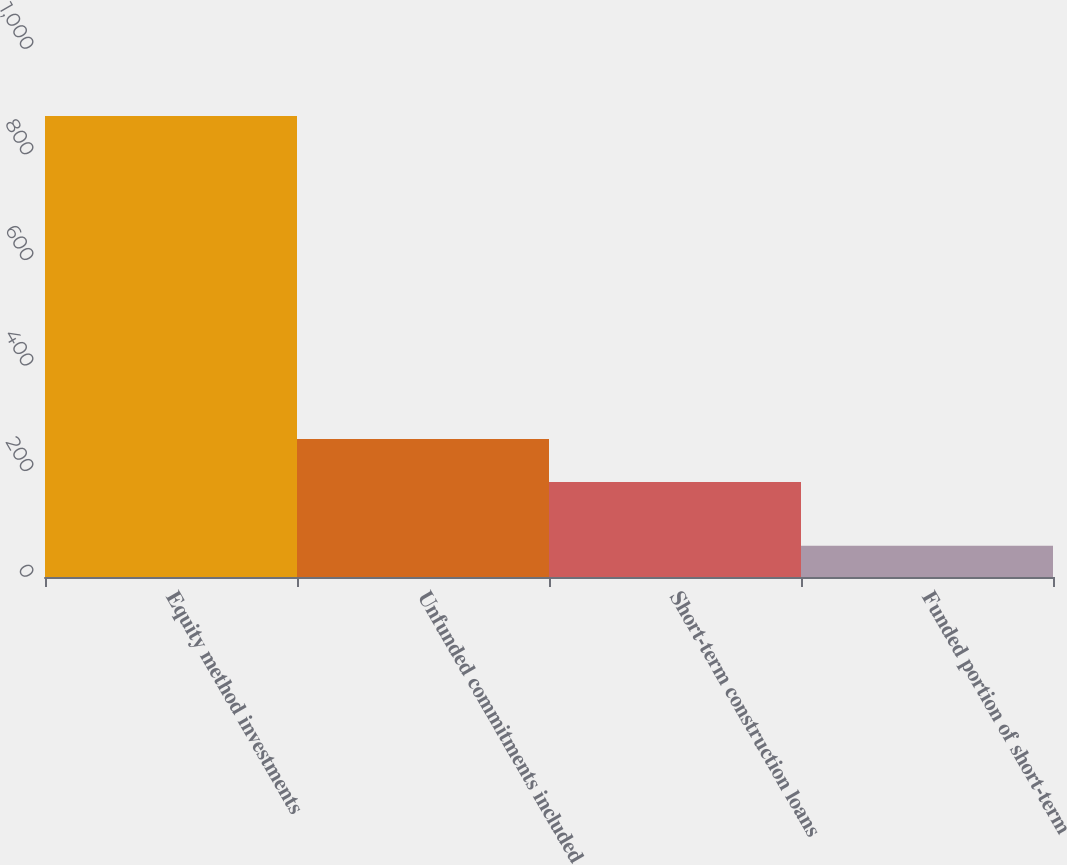<chart> <loc_0><loc_0><loc_500><loc_500><bar_chart><fcel>Equity method investments<fcel>Unfunded commitments included<fcel>Short-term construction loans<fcel>Funded portion of short-term<nl><fcel>873<fcel>261.4<fcel>180<fcel>59<nl></chart> 